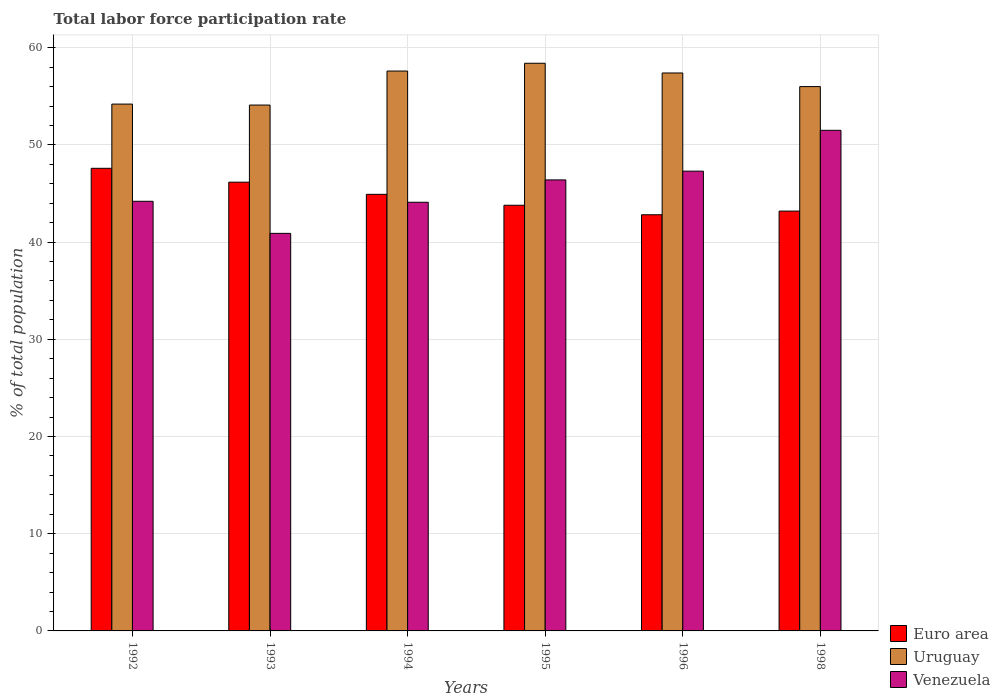How many groups of bars are there?
Provide a short and direct response. 6. Are the number of bars per tick equal to the number of legend labels?
Offer a terse response. Yes. Are the number of bars on each tick of the X-axis equal?
Ensure brevity in your answer.  Yes. How many bars are there on the 3rd tick from the right?
Your response must be concise. 3. In how many cases, is the number of bars for a given year not equal to the number of legend labels?
Provide a succinct answer. 0. What is the total labor force participation rate in Uruguay in 1996?
Your answer should be compact. 57.4. Across all years, what is the maximum total labor force participation rate in Euro area?
Make the answer very short. 47.59. Across all years, what is the minimum total labor force participation rate in Venezuela?
Your answer should be very brief. 40.9. In which year was the total labor force participation rate in Euro area maximum?
Your answer should be compact. 1992. What is the total total labor force participation rate in Venezuela in the graph?
Provide a succinct answer. 274.4. What is the difference between the total labor force participation rate in Euro area in 1996 and that in 1998?
Your answer should be compact. -0.38. What is the difference between the total labor force participation rate in Euro area in 1998 and the total labor force participation rate in Venezuela in 1996?
Keep it short and to the point. -4.11. What is the average total labor force participation rate in Uruguay per year?
Make the answer very short. 56.28. In the year 1994, what is the difference between the total labor force participation rate in Euro area and total labor force participation rate in Uruguay?
Provide a short and direct response. -12.69. What is the ratio of the total labor force participation rate in Euro area in 1996 to that in 1998?
Offer a terse response. 0.99. Is the total labor force participation rate in Venezuela in 1993 less than that in 1994?
Make the answer very short. Yes. Is the difference between the total labor force participation rate in Euro area in 1993 and 1994 greater than the difference between the total labor force participation rate in Uruguay in 1993 and 1994?
Provide a succinct answer. Yes. What is the difference between the highest and the second highest total labor force participation rate in Euro area?
Offer a very short reply. 1.43. What is the difference between the highest and the lowest total labor force participation rate in Uruguay?
Make the answer very short. 4.3. In how many years, is the total labor force participation rate in Euro area greater than the average total labor force participation rate in Euro area taken over all years?
Make the answer very short. 3. What does the 2nd bar from the right in 1993 represents?
Give a very brief answer. Uruguay. Is it the case that in every year, the sum of the total labor force participation rate in Venezuela and total labor force participation rate in Euro area is greater than the total labor force participation rate in Uruguay?
Your response must be concise. Yes. How many bars are there?
Keep it short and to the point. 18. Are all the bars in the graph horizontal?
Your response must be concise. No. How many years are there in the graph?
Make the answer very short. 6. What is the difference between two consecutive major ticks on the Y-axis?
Make the answer very short. 10. Does the graph contain any zero values?
Ensure brevity in your answer.  No. Does the graph contain grids?
Ensure brevity in your answer.  Yes. How many legend labels are there?
Your answer should be compact. 3. What is the title of the graph?
Offer a terse response. Total labor force participation rate. Does "Cayman Islands" appear as one of the legend labels in the graph?
Ensure brevity in your answer.  No. What is the label or title of the Y-axis?
Ensure brevity in your answer.  % of total population. What is the % of total population of Euro area in 1992?
Ensure brevity in your answer.  47.59. What is the % of total population of Uruguay in 1992?
Offer a very short reply. 54.2. What is the % of total population in Venezuela in 1992?
Your answer should be compact. 44.2. What is the % of total population in Euro area in 1993?
Your response must be concise. 46.17. What is the % of total population in Uruguay in 1993?
Provide a short and direct response. 54.1. What is the % of total population in Venezuela in 1993?
Provide a short and direct response. 40.9. What is the % of total population in Euro area in 1994?
Your answer should be very brief. 44.91. What is the % of total population of Uruguay in 1994?
Ensure brevity in your answer.  57.6. What is the % of total population of Venezuela in 1994?
Your response must be concise. 44.1. What is the % of total population of Euro area in 1995?
Provide a short and direct response. 43.79. What is the % of total population of Uruguay in 1995?
Offer a very short reply. 58.4. What is the % of total population of Venezuela in 1995?
Provide a succinct answer. 46.4. What is the % of total population of Euro area in 1996?
Offer a terse response. 42.81. What is the % of total population in Uruguay in 1996?
Make the answer very short. 57.4. What is the % of total population in Venezuela in 1996?
Provide a short and direct response. 47.3. What is the % of total population in Euro area in 1998?
Provide a short and direct response. 43.19. What is the % of total population of Venezuela in 1998?
Your response must be concise. 51.5. Across all years, what is the maximum % of total population of Euro area?
Your answer should be compact. 47.59. Across all years, what is the maximum % of total population of Uruguay?
Provide a short and direct response. 58.4. Across all years, what is the maximum % of total population in Venezuela?
Your answer should be compact. 51.5. Across all years, what is the minimum % of total population in Euro area?
Your answer should be very brief. 42.81. Across all years, what is the minimum % of total population in Uruguay?
Give a very brief answer. 54.1. Across all years, what is the minimum % of total population of Venezuela?
Provide a short and direct response. 40.9. What is the total % of total population of Euro area in the graph?
Your answer should be very brief. 268.47. What is the total % of total population of Uruguay in the graph?
Ensure brevity in your answer.  337.7. What is the total % of total population in Venezuela in the graph?
Keep it short and to the point. 274.4. What is the difference between the % of total population in Euro area in 1992 and that in 1993?
Ensure brevity in your answer.  1.43. What is the difference between the % of total population in Euro area in 1992 and that in 1994?
Offer a terse response. 2.68. What is the difference between the % of total population of Uruguay in 1992 and that in 1994?
Your answer should be very brief. -3.4. What is the difference between the % of total population in Venezuela in 1992 and that in 1994?
Give a very brief answer. 0.1. What is the difference between the % of total population in Euro area in 1992 and that in 1995?
Ensure brevity in your answer.  3.8. What is the difference between the % of total population of Venezuela in 1992 and that in 1995?
Offer a very short reply. -2.2. What is the difference between the % of total population of Euro area in 1992 and that in 1996?
Give a very brief answer. 4.78. What is the difference between the % of total population in Uruguay in 1992 and that in 1996?
Your answer should be very brief. -3.2. What is the difference between the % of total population in Venezuela in 1992 and that in 1996?
Offer a very short reply. -3.1. What is the difference between the % of total population in Euro area in 1992 and that in 1998?
Provide a short and direct response. 4.4. What is the difference between the % of total population of Uruguay in 1992 and that in 1998?
Ensure brevity in your answer.  -1.8. What is the difference between the % of total population in Venezuela in 1992 and that in 1998?
Offer a very short reply. -7.3. What is the difference between the % of total population of Euro area in 1993 and that in 1994?
Make the answer very short. 1.25. What is the difference between the % of total population of Uruguay in 1993 and that in 1994?
Give a very brief answer. -3.5. What is the difference between the % of total population of Venezuela in 1993 and that in 1994?
Provide a short and direct response. -3.2. What is the difference between the % of total population in Euro area in 1993 and that in 1995?
Offer a terse response. 2.38. What is the difference between the % of total population of Uruguay in 1993 and that in 1995?
Ensure brevity in your answer.  -4.3. What is the difference between the % of total population of Euro area in 1993 and that in 1996?
Your response must be concise. 3.35. What is the difference between the % of total population of Uruguay in 1993 and that in 1996?
Make the answer very short. -3.3. What is the difference between the % of total population in Venezuela in 1993 and that in 1996?
Give a very brief answer. -6.4. What is the difference between the % of total population in Euro area in 1993 and that in 1998?
Make the answer very short. 2.98. What is the difference between the % of total population in Uruguay in 1993 and that in 1998?
Provide a succinct answer. -1.9. What is the difference between the % of total population of Venezuela in 1993 and that in 1998?
Your answer should be compact. -10.6. What is the difference between the % of total population in Euro area in 1994 and that in 1995?
Ensure brevity in your answer.  1.12. What is the difference between the % of total population in Uruguay in 1994 and that in 1995?
Provide a short and direct response. -0.8. What is the difference between the % of total population of Euro area in 1994 and that in 1996?
Provide a short and direct response. 2.1. What is the difference between the % of total population of Venezuela in 1994 and that in 1996?
Make the answer very short. -3.2. What is the difference between the % of total population of Euro area in 1994 and that in 1998?
Provide a short and direct response. 1.72. What is the difference between the % of total population of Uruguay in 1994 and that in 1998?
Offer a very short reply. 1.6. What is the difference between the % of total population in Venezuela in 1994 and that in 1998?
Keep it short and to the point. -7.4. What is the difference between the % of total population of Euro area in 1995 and that in 1996?
Your answer should be compact. 0.98. What is the difference between the % of total population in Uruguay in 1995 and that in 1996?
Provide a short and direct response. 1. What is the difference between the % of total population of Euro area in 1995 and that in 1998?
Your answer should be very brief. 0.6. What is the difference between the % of total population in Uruguay in 1995 and that in 1998?
Make the answer very short. 2.4. What is the difference between the % of total population of Venezuela in 1995 and that in 1998?
Your answer should be very brief. -5.1. What is the difference between the % of total population of Euro area in 1996 and that in 1998?
Ensure brevity in your answer.  -0.38. What is the difference between the % of total population in Uruguay in 1996 and that in 1998?
Offer a very short reply. 1.4. What is the difference between the % of total population of Euro area in 1992 and the % of total population of Uruguay in 1993?
Provide a succinct answer. -6.51. What is the difference between the % of total population of Euro area in 1992 and the % of total population of Venezuela in 1993?
Your answer should be compact. 6.69. What is the difference between the % of total population of Uruguay in 1992 and the % of total population of Venezuela in 1993?
Your answer should be compact. 13.3. What is the difference between the % of total population of Euro area in 1992 and the % of total population of Uruguay in 1994?
Ensure brevity in your answer.  -10.01. What is the difference between the % of total population in Euro area in 1992 and the % of total population in Venezuela in 1994?
Offer a terse response. 3.49. What is the difference between the % of total population in Uruguay in 1992 and the % of total population in Venezuela in 1994?
Give a very brief answer. 10.1. What is the difference between the % of total population of Euro area in 1992 and the % of total population of Uruguay in 1995?
Your answer should be compact. -10.81. What is the difference between the % of total population in Euro area in 1992 and the % of total population in Venezuela in 1995?
Keep it short and to the point. 1.19. What is the difference between the % of total population in Uruguay in 1992 and the % of total population in Venezuela in 1995?
Provide a short and direct response. 7.8. What is the difference between the % of total population of Euro area in 1992 and the % of total population of Uruguay in 1996?
Your response must be concise. -9.81. What is the difference between the % of total population in Euro area in 1992 and the % of total population in Venezuela in 1996?
Give a very brief answer. 0.29. What is the difference between the % of total population of Euro area in 1992 and the % of total population of Uruguay in 1998?
Offer a very short reply. -8.41. What is the difference between the % of total population in Euro area in 1992 and the % of total population in Venezuela in 1998?
Your answer should be compact. -3.91. What is the difference between the % of total population of Euro area in 1993 and the % of total population of Uruguay in 1994?
Offer a terse response. -11.43. What is the difference between the % of total population of Euro area in 1993 and the % of total population of Venezuela in 1994?
Offer a terse response. 2.07. What is the difference between the % of total population of Euro area in 1993 and the % of total population of Uruguay in 1995?
Provide a succinct answer. -12.23. What is the difference between the % of total population in Euro area in 1993 and the % of total population in Venezuela in 1995?
Your answer should be compact. -0.23. What is the difference between the % of total population in Uruguay in 1993 and the % of total population in Venezuela in 1995?
Your answer should be compact. 7.7. What is the difference between the % of total population of Euro area in 1993 and the % of total population of Uruguay in 1996?
Your answer should be very brief. -11.23. What is the difference between the % of total population of Euro area in 1993 and the % of total population of Venezuela in 1996?
Provide a succinct answer. -1.13. What is the difference between the % of total population in Uruguay in 1993 and the % of total population in Venezuela in 1996?
Keep it short and to the point. 6.8. What is the difference between the % of total population in Euro area in 1993 and the % of total population in Uruguay in 1998?
Keep it short and to the point. -9.83. What is the difference between the % of total population in Euro area in 1993 and the % of total population in Venezuela in 1998?
Your answer should be compact. -5.33. What is the difference between the % of total population in Uruguay in 1993 and the % of total population in Venezuela in 1998?
Give a very brief answer. 2.6. What is the difference between the % of total population in Euro area in 1994 and the % of total population in Uruguay in 1995?
Your response must be concise. -13.49. What is the difference between the % of total population of Euro area in 1994 and the % of total population of Venezuela in 1995?
Offer a terse response. -1.49. What is the difference between the % of total population in Uruguay in 1994 and the % of total population in Venezuela in 1995?
Offer a terse response. 11.2. What is the difference between the % of total population of Euro area in 1994 and the % of total population of Uruguay in 1996?
Keep it short and to the point. -12.49. What is the difference between the % of total population of Euro area in 1994 and the % of total population of Venezuela in 1996?
Your answer should be compact. -2.39. What is the difference between the % of total population in Uruguay in 1994 and the % of total population in Venezuela in 1996?
Provide a succinct answer. 10.3. What is the difference between the % of total population in Euro area in 1994 and the % of total population in Uruguay in 1998?
Provide a short and direct response. -11.09. What is the difference between the % of total population in Euro area in 1994 and the % of total population in Venezuela in 1998?
Provide a short and direct response. -6.59. What is the difference between the % of total population of Uruguay in 1994 and the % of total population of Venezuela in 1998?
Offer a terse response. 6.1. What is the difference between the % of total population of Euro area in 1995 and the % of total population of Uruguay in 1996?
Your answer should be compact. -13.61. What is the difference between the % of total population of Euro area in 1995 and the % of total population of Venezuela in 1996?
Provide a short and direct response. -3.51. What is the difference between the % of total population in Euro area in 1995 and the % of total population in Uruguay in 1998?
Your response must be concise. -12.21. What is the difference between the % of total population in Euro area in 1995 and the % of total population in Venezuela in 1998?
Offer a very short reply. -7.71. What is the difference between the % of total population in Uruguay in 1995 and the % of total population in Venezuela in 1998?
Your answer should be compact. 6.9. What is the difference between the % of total population in Euro area in 1996 and the % of total population in Uruguay in 1998?
Your answer should be very brief. -13.19. What is the difference between the % of total population of Euro area in 1996 and the % of total population of Venezuela in 1998?
Ensure brevity in your answer.  -8.69. What is the average % of total population of Euro area per year?
Your response must be concise. 44.75. What is the average % of total population in Uruguay per year?
Provide a succinct answer. 56.28. What is the average % of total population in Venezuela per year?
Provide a succinct answer. 45.73. In the year 1992, what is the difference between the % of total population of Euro area and % of total population of Uruguay?
Your answer should be very brief. -6.61. In the year 1992, what is the difference between the % of total population of Euro area and % of total population of Venezuela?
Provide a short and direct response. 3.39. In the year 1992, what is the difference between the % of total population of Uruguay and % of total population of Venezuela?
Ensure brevity in your answer.  10. In the year 1993, what is the difference between the % of total population in Euro area and % of total population in Uruguay?
Keep it short and to the point. -7.93. In the year 1993, what is the difference between the % of total population in Euro area and % of total population in Venezuela?
Your response must be concise. 5.27. In the year 1993, what is the difference between the % of total population of Uruguay and % of total population of Venezuela?
Offer a very short reply. 13.2. In the year 1994, what is the difference between the % of total population of Euro area and % of total population of Uruguay?
Ensure brevity in your answer.  -12.69. In the year 1994, what is the difference between the % of total population in Euro area and % of total population in Venezuela?
Your answer should be very brief. 0.81. In the year 1995, what is the difference between the % of total population of Euro area and % of total population of Uruguay?
Give a very brief answer. -14.61. In the year 1995, what is the difference between the % of total population of Euro area and % of total population of Venezuela?
Your answer should be compact. -2.61. In the year 1996, what is the difference between the % of total population in Euro area and % of total population in Uruguay?
Provide a short and direct response. -14.59. In the year 1996, what is the difference between the % of total population in Euro area and % of total population in Venezuela?
Offer a very short reply. -4.49. In the year 1996, what is the difference between the % of total population of Uruguay and % of total population of Venezuela?
Your answer should be compact. 10.1. In the year 1998, what is the difference between the % of total population of Euro area and % of total population of Uruguay?
Provide a succinct answer. -12.81. In the year 1998, what is the difference between the % of total population of Euro area and % of total population of Venezuela?
Make the answer very short. -8.31. In the year 1998, what is the difference between the % of total population in Uruguay and % of total population in Venezuela?
Provide a succinct answer. 4.5. What is the ratio of the % of total population in Euro area in 1992 to that in 1993?
Give a very brief answer. 1.03. What is the ratio of the % of total population of Venezuela in 1992 to that in 1993?
Offer a very short reply. 1.08. What is the ratio of the % of total population in Euro area in 1992 to that in 1994?
Your answer should be compact. 1.06. What is the ratio of the % of total population in Uruguay in 1992 to that in 1994?
Offer a terse response. 0.94. What is the ratio of the % of total population in Venezuela in 1992 to that in 1994?
Offer a very short reply. 1. What is the ratio of the % of total population of Euro area in 1992 to that in 1995?
Keep it short and to the point. 1.09. What is the ratio of the % of total population of Uruguay in 1992 to that in 1995?
Ensure brevity in your answer.  0.93. What is the ratio of the % of total population in Venezuela in 1992 to that in 1995?
Provide a succinct answer. 0.95. What is the ratio of the % of total population of Euro area in 1992 to that in 1996?
Make the answer very short. 1.11. What is the ratio of the % of total population in Uruguay in 1992 to that in 1996?
Your answer should be compact. 0.94. What is the ratio of the % of total population in Venezuela in 1992 to that in 1996?
Keep it short and to the point. 0.93. What is the ratio of the % of total population in Euro area in 1992 to that in 1998?
Make the answer very short. 1.1. What is the ratio of the % of total population of Uruguay in 1992 to that in 1998?
Offer a very short reply. 0.97. What is the ratio of the % of total population of Venezuela in 1992 to that in 1998?
Offer a very short reply. 0.86. What is the ratio of the % of total population in Euro area in 1993 to that in 1994?
Make the answer very short. 1.03. What is the ratio of the % of total population of Uruguay in 1993 to that in 1994?
Offer a terse response. 0.94. What is the ratio of the % of total population in Venezuela in 1993 to that in 1994?
Make the answer very short. 0.93. What is the ratio of the % of total population of Euro area in 1993 to that in 1995?
Ensure brevity in your answer.  1.05. What is the ratio of the % of total population of Uruguay in 1993 to that in 1995?
Offer a terse response. 0.93. What is the ratio of the % of total population in Venezuela in 1993 to that in 1995?
Provide a succinct answer. 0.88. What is the ratio of the % of total population of Euro area in 1993 to that in 1996?
Keep it short and to the point. 1.08. What is the ratio of the % of total population of Uruguay in 1993 to that in 1996?
Ensure brevity in your answer.  0.94. What is the ratio of the % of total population of Venezuela in 1993 to that in 1996?
Provide a succinct answer. 0.86. What is the ratio of the % of total population in Euro area in 1993 to that in 1998?
Make the answer very short. 1.07. What is the ratio of the % of total population in Uruguay in 1993 to that in 1998?
Offer a terse response. 0.97. What is the ratio of the % of total population in Venezuela in 1993 to that in 1998?
Provide a succinct answer. 0.79. What is the ratio of the % of total population of Euro area in 1994 to that in 1995?
Your answer should be very brief. 1.03. What is the ratio of the % of total population of Uruguay in 1994 to that in 1995?
Offer a very short reply. 0.99. What is the ratio of the % of total population in Venezuela in 1994 to that in 1995?
Your response must be concise. 0.95. What is the ratio of the % of total population of Euro area in 1994 to that in 1996?
Give a very brief answer. 1.05. What is the ratio of the % of total population of Uruguay in 1994 to that in 1996?
Keep it short and to the point. 1. What is the ratio of the % of total population of Venezuela in 1994 to that in 1996?
Provide a short and direct response. 0.93. What is the ratio of the % of total population in Euro area in 1994 to that in 1998?
Give a very brief answer. 1.04. What is the ratio of the % of total population of Uruguay in 1994 to that in 1998?
Provide a short and direct response. 1.03. What is the ratio of the % of total population of Venezuela in 1994 to that in 1998?
Give a very brief answer. 0.86. What is the ratio of the % of total population in Euro area in 1995 to that in 1996?
Make the answer very short. 1.02. What is the ratio of the % of total population of Uruguay in 1995 to that in 1996?
Offer a very short reply. 1.02. What is the ratio of the % of total population in Venezuela in 1995 to that in 1996?
Give a very brief answer. 0.98. What is the ratio of the % of total population in Euro area in 1995 to that in 1998?
Provide a short and direct response. 1.01. What is the ratio of the % of total population of Uruguay in 1995 to that in 1998?
Your answer should be very brief. 1.04. What is the ratio of the % of total population of Venezuela in 1995 to that in 1998?
Your answer should be very brief. 0.9. What is the ratio of the % of total population in Uruguay in 1996 to that in 1998?
Offer a very short reply. 1.02. What is the ratio of the % of total population in Venezuela in 1996 to that in 1998?
Your answer should be very brief. 0.92. What is the difference between the highest and the second highest % of total population of Euro area?
Keep it short and to the point. 1.43. What is the difference between the highest and the second highest % of total population in Venezuela?
Your answer should be very brief. 4.2. What is the difference between the highest and the lowest % of total population in Euro area?
Offer a terse response. 4.78. What is the difference between the highest and the lowest % of total population of Uruguay?
Give a very brief answer. 4.3. 